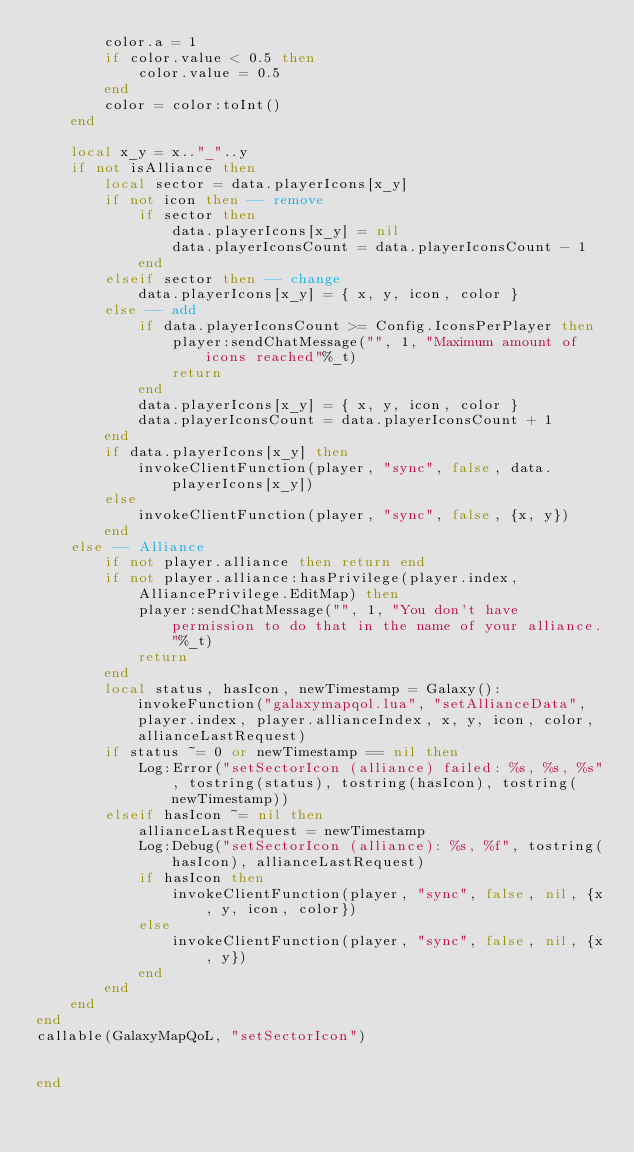<code> <loc_0><loc_0><loc_500><loc_500><_Lua_>        color.a = 1
        if color.value < 0.5 then
            color.value = 0.5
        end
        color = color:toInt()
    end

    local x_y = x.."_"..y
    if not isAlliance then
        local sector = data.playerIcons[x_y]
        if not icon then -- remove
            if sector then
                data.playerIcons[x_y] = nil
                data.playerIconsCount = data.playerIconsCount - 1
            end
        elseif sector then -- change
            data.playerIcons[x_y] = { x, y, icon, color }
        else -- add
            if data.playerIconsCount >= Config.IconsPerPlayer then
                player:sendChatMessage("", 1, "Maximum amount of icons reached"%_t)
                return
            end
            data.playerIcons[x_y] = { x, y, icon, color }
            data.playerIconsCount = data.playerIconsCount + 1
        end
        if data.playerIcons[x_y] then
            invokeClientFunction(player, "sync", false, data.playerIcons[x_y])
        else
            invokeClientFunction(player, "sync", false, {x, y})
        end
    else -- Alliance
        if not player.alliance then return end
        if not player.alliance:hasPrivilege(player.index, AlliancePrivilege.EditMap) then
            player:sendChatMessage("", 1, "You don't have permission to do that in the name of your alliance."%_t)
            return
        end
        local status, hasIcon, newTimestamp = Galaxy():invokeFunction("galaxymapqol.lua", "setAllianceData", player.index, player.allianceIndex, x, y, icon, color, allianceLastRequest)
        if status ~= 0 or newTimestamp == nil then
            Log:Error("setSectorIcon (alliance) failed: %s, %s, %s", tostring(status), tostring(hasIcon), tostring(newTimestamp))
        elseif hasIcon ~= nil then
            allianceLastRequest = newTimestamp
            Log:Debug("setSectorIcon (alliance): %s, %f", tostring(hasIcon), allianceLastRequest)
            if hasIcon then
                invokeClientFunction(player, "sync", false, nil, {x, y, icon, color})
            else
                invokeClientFunction(player, "sync", false, nil, {x, y})
            end
        end
    end
end
callable(GalaxyMapQoL, "setSectorIcon")


end</code> 